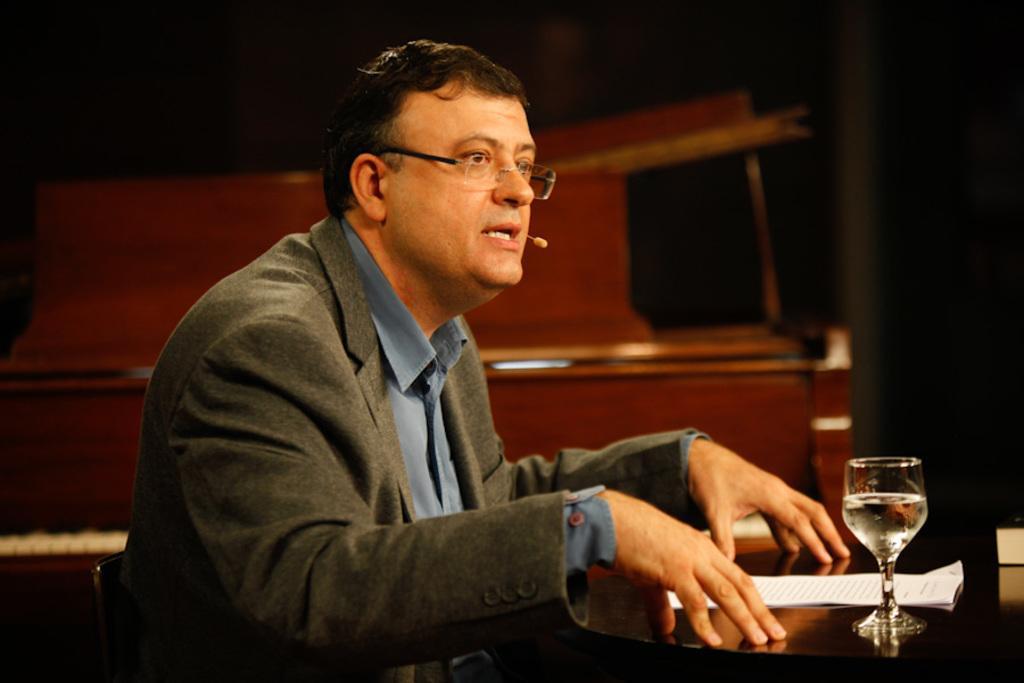Can you describe this image briefly? In this image, there is a person wearing spectacles and sitting on the chair in front of the table. This table contains a glass and some papers. 